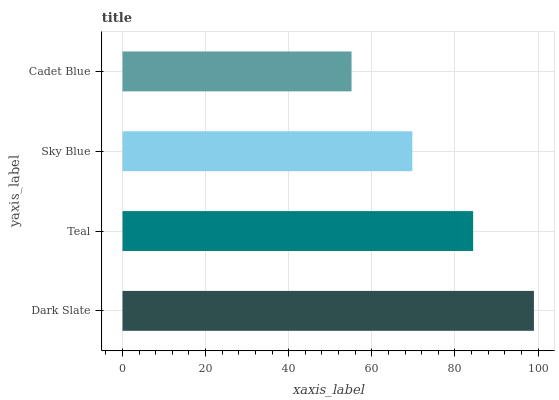Is Cadet Blue the minimum?
Answer yes or no. Yes. Is Dark Slate the maximum?
Answer yes or no. Yes. Is Teal the minimum?
Answer yes or no. No. Is Teal the maximum?
Answer yes or no. No. Is Dark Slate greater than Teal?
Answer yes or no. Yes. Is Teal less than Dark Slate?
Answer yes or no. Yes. Is Teal greater than Dark Slate?
Answer yes or no. No. Is Dark Slate less than Teal?
Answer yes or no. No. Is Teal the high median?
Answer yes or no. Yes. Is Sky Blue the low median?
Answer yes or no. Yes. Is Cadet Blue the high median?
Answer yes or no. No. Is Teal the low median?
Answer yes or no. No. 